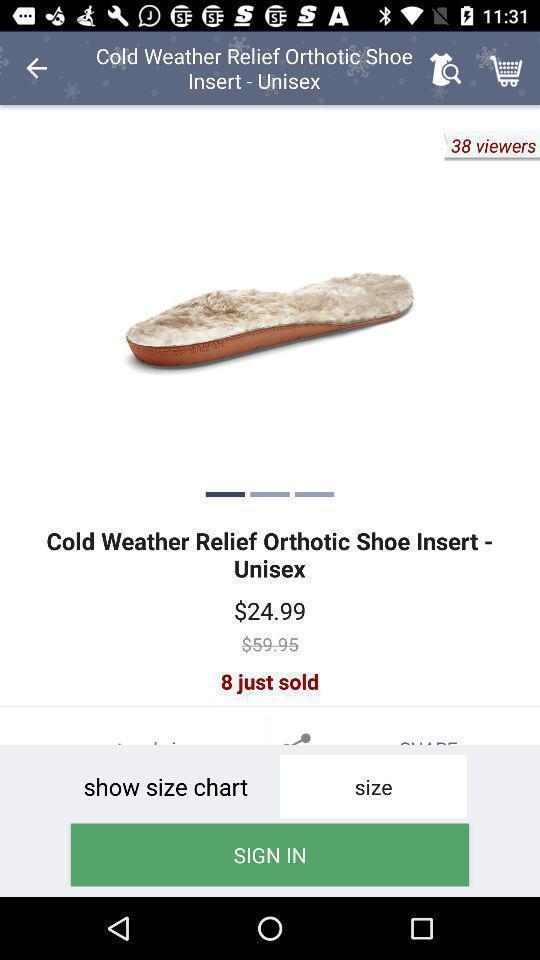Provide a textual representation of this image. Screen displaying product details with image and price. 